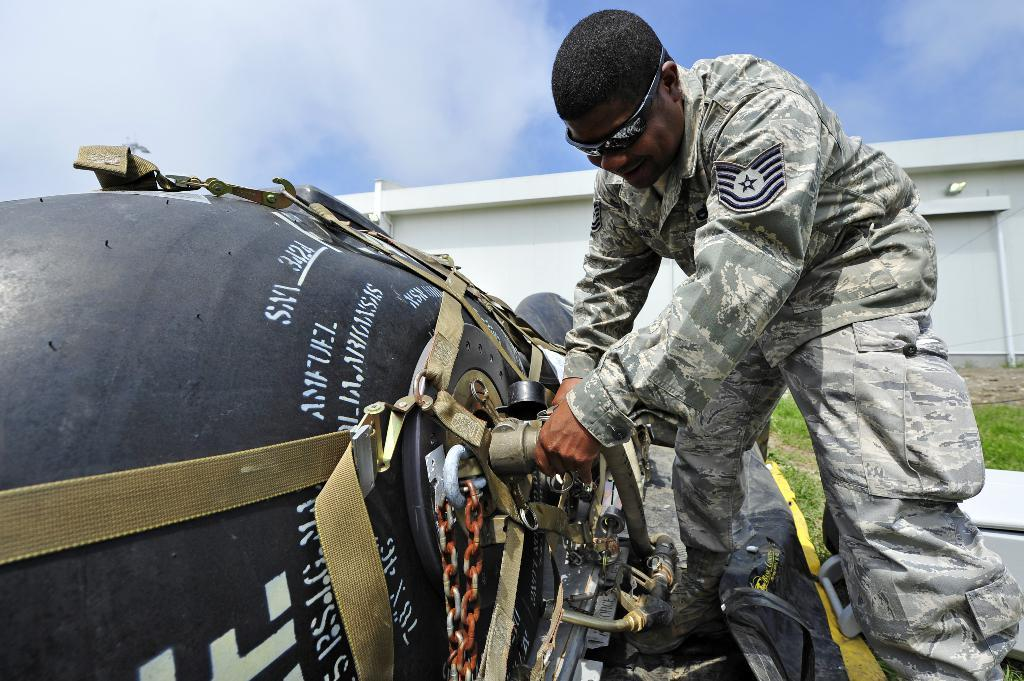What is the person in the image doing? The person is repairing something. What type of environment is visible in the image? There is grass in the image, suggesting an outdoor setting. What structure can be seen in the image? There is a garage in the image. What is visible in the background of the image? The sky is visible in the background of the image. What type of zipper can be seen on the person's clothing in the image? There is no zipper visible on the person's clothing in the image. How many pets are present in the image? There are no pets present in the image. 